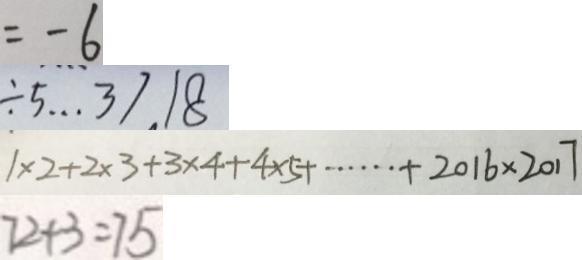Convert formula to latex. <formula><loc_0><loc_0><loc_500><loc_500>= - 6 
 \div 5 \cdots 3 7 . 1 8 
 1 \times 2 + 2 \times 3 + 3 \times 4 + 4 \times 5 + \cdots + 2 0 1 6 \times 2 0 1 7 
 7 2 + 3 = 7 5</formula> 